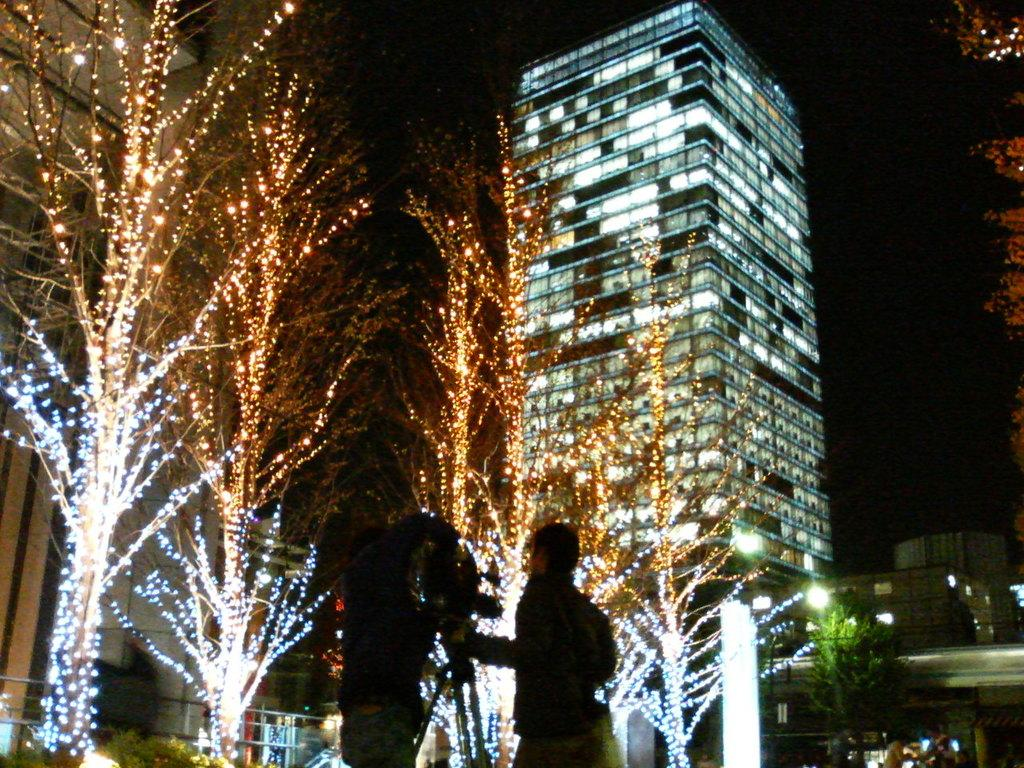How many people are in the image? There are two people standing in front of the camera. What is in front of the people in the image? There are trees in front of the people. Can you describe any artificial light sources in the image? Yes, there are lights visible in the image. What type of structures can be seen in the image? There are buildings in the image. What is visible in the background of the image? The sky is visible in the background of the image. What type of arch can be seen in the image? There is no arch present in the image. How many cattle are visible in the image? There are no cattle present in the image. 